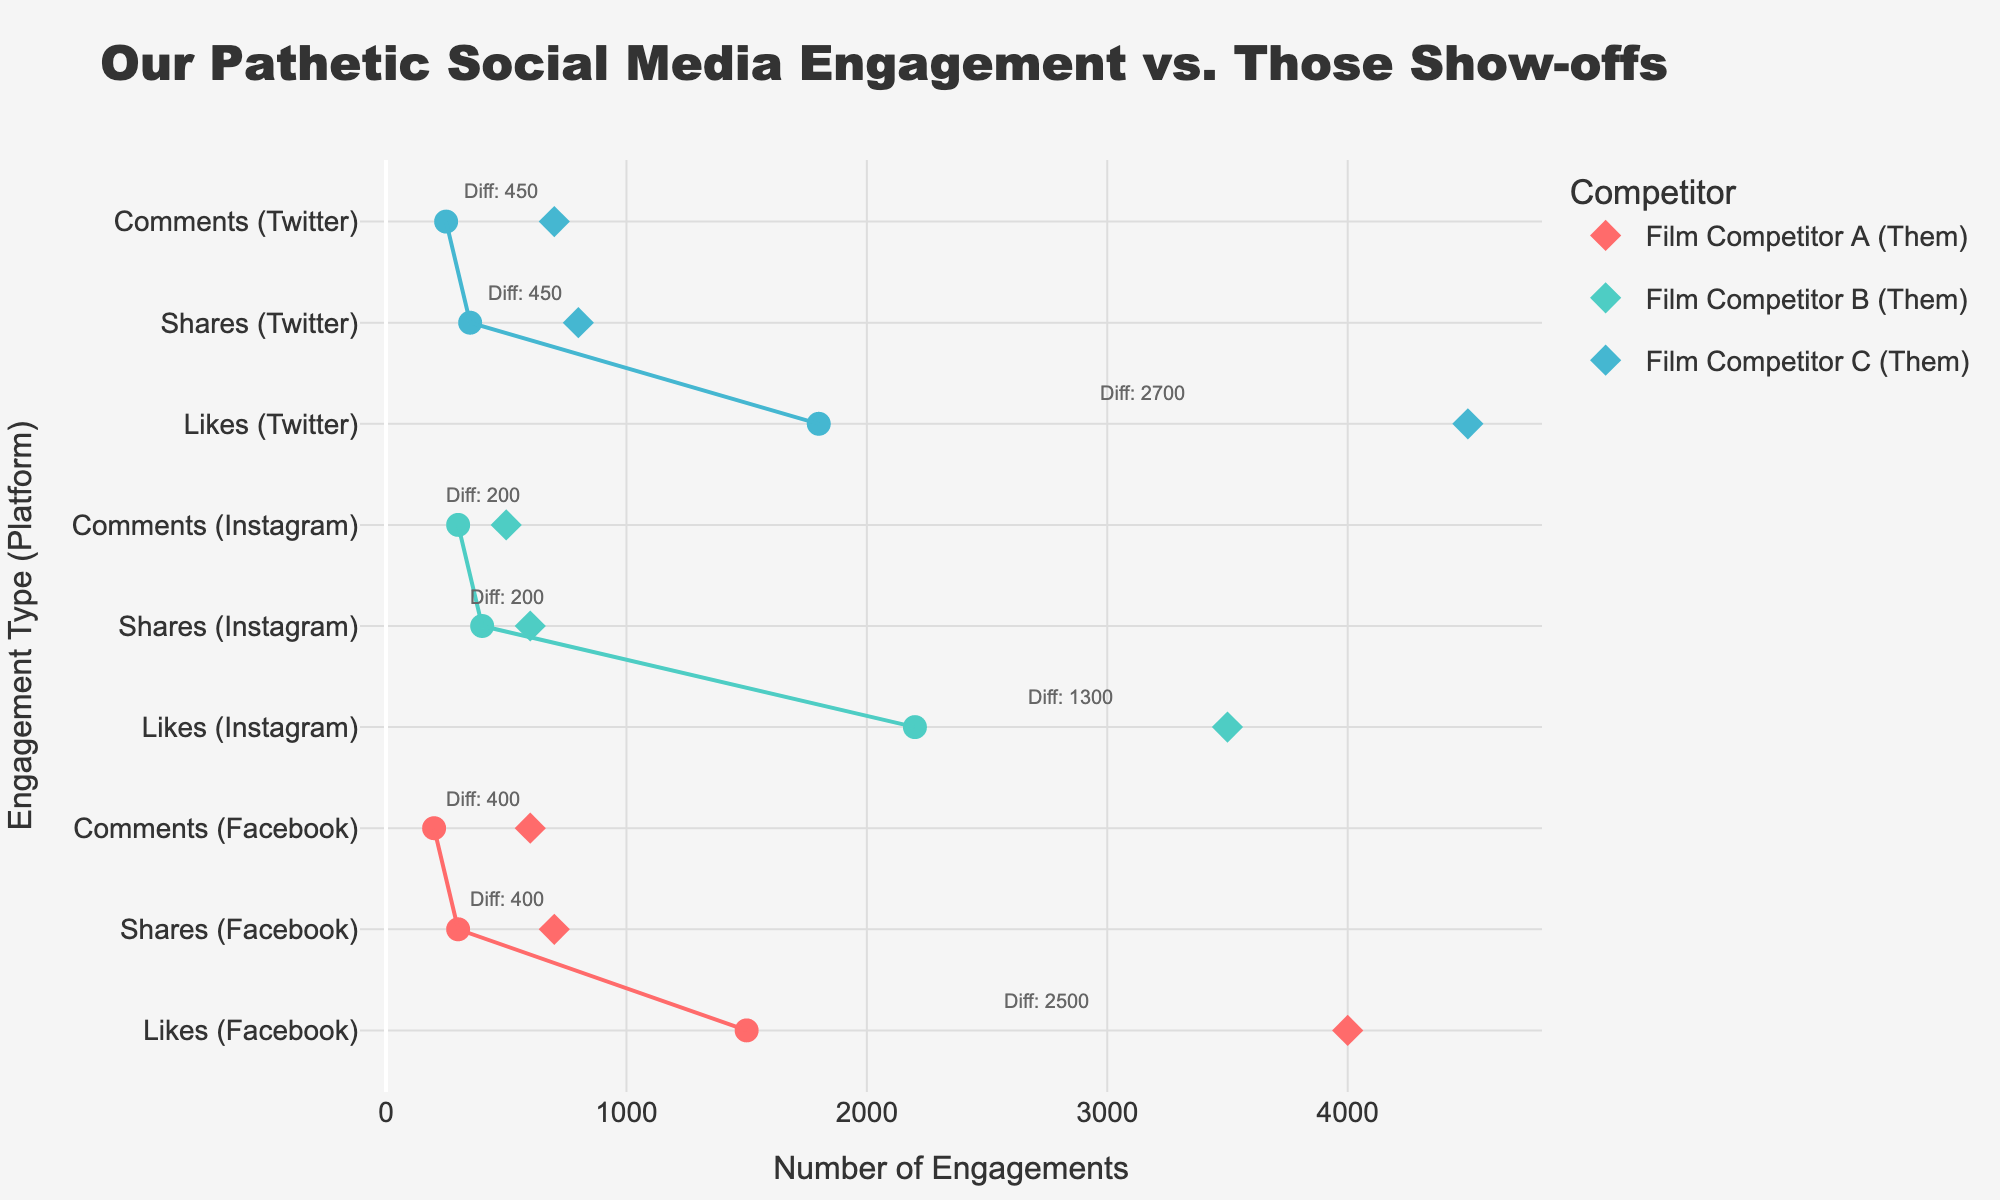What is the title of the plot? The title is usually given at the top of the plot. In this plot, the title is "Our Pathetic Social Media Engagement vs. Those Show-offs."
Answer: Our Pathetic Social Media Engagement vs. Those Show-offs Which platform has the smallest difference in likes between your film and Competitor B's film? By checking the likes data for Competitor B on all platforms, we see Instagram has 2200 likes for your film and 3500 likes for Competitor B, a difference of 1300 which is the smallest compared to other platforms for this competitor.
Answer: Instagram On which social media platform does Competitor C outperform you the most in shares? Look at the share counts for Competitor C across all platforms. The number of shares for Competitor C is highest on Twitter (800), making the difference (450) the greatest there.
Answer: Twitter How many types of engagement data are displayed on the plot? The types of engagement are usually indicated by different y-axis labels. Here, we have Likes, Shares, and Comments.
Answer: 3 What is the color used to represent Competitor A in the plot? Look at the plot legend and the markers for Competitor A. The markers for Competitor A are colored with a reddish hue.
Answer: Red Calculate the average number of likes for your film across all platforms. Add the likes for your film on Facebook (1500), Instagram (2200), and Twitter (1800), then divide by 3. (1500 + 2200 + 1800) / 3 = 5500 / 3 = 1833.33
Answer: 1833.33 Which competitor has the highest total number of comments on their film across all platforms? Sum the comments for each competitor: 
Competitor A: 600 (Facebook)
Competitor B: 500 (Instagram)
Competitor C: 700 (Twitter).
The highest total is 700 for Competitor C.
Answer: Competitor C Between you and Competitor A, who has a higher number of comments on Facebook? Look at the comments data for Facebook. You have 200 comments, whereas Competitor A has 600 comments. Since 600 > 200, Competitor A has more.
Answer: Competitor A Is there any platform where your film has more likes than the competitor's film? Compare the likes on all platforms. Your film has 1500 likes on Facebook, 2200 on Instagram, and 1800 on Twitter. In all cases, the competitor's film has more likes.
Answer: No Which platform and engagement type combination shows the largest difference between your film and Competitor C's film? Check the differences across all combinations for Competitor C to find: 
Likes (Twitter): 4500 - 1800 = 2700
Shares (Twitter): 800 - 350 = 450
Comments (Twitter): 700 - 250 = 450.
The largest difference is for Likes (Twitter) with a difference of 2700.
Answer: Twitter, Likes 